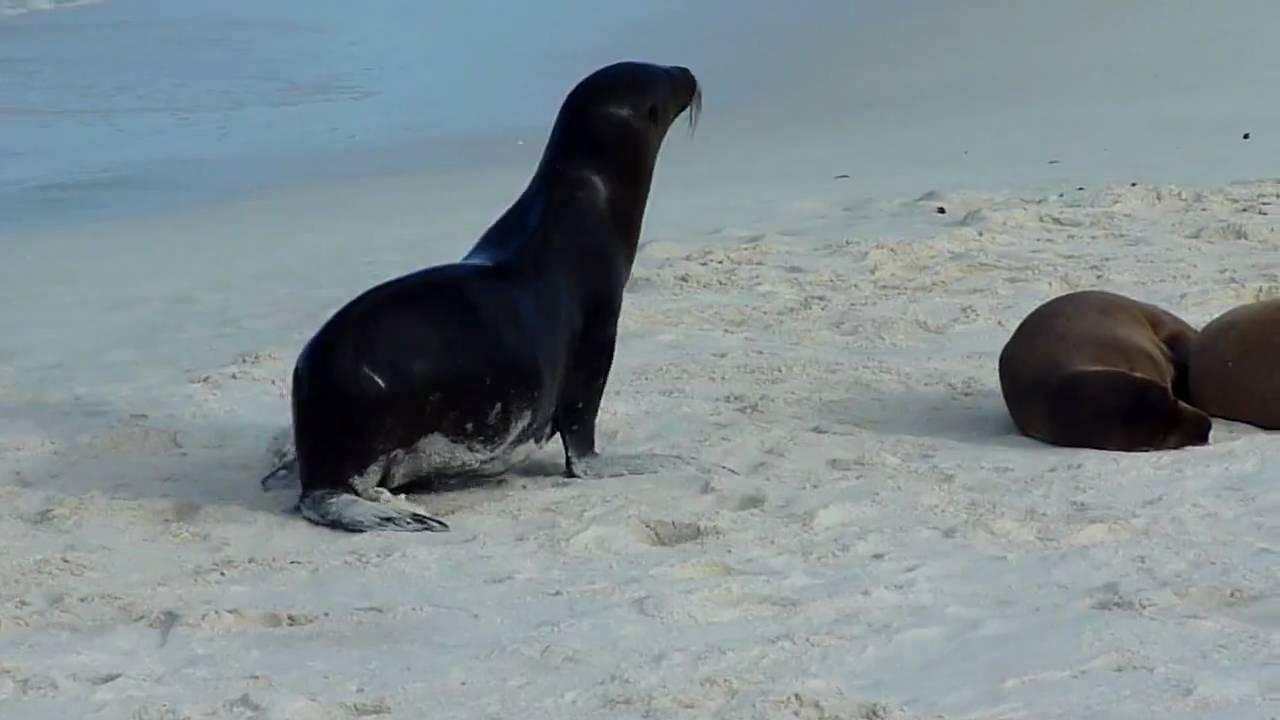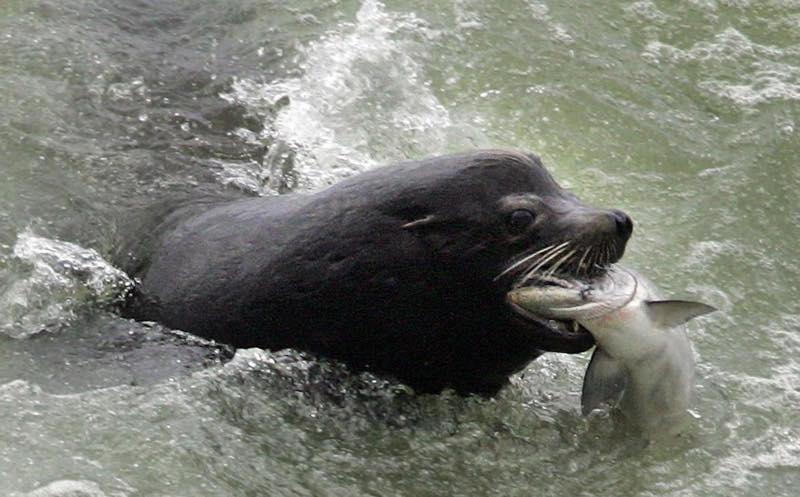The first image is the image on the left, the second image is the image on the right. Given the left and right images, does the statement "A seal is catching a fish." hold true? Answer yes or no. Yes. The first image is the image on the left, the second image is the image on the right. Considering the images on both sides, is "The right image contains no more than one seal." valid? Answer yes or no. Yes. 